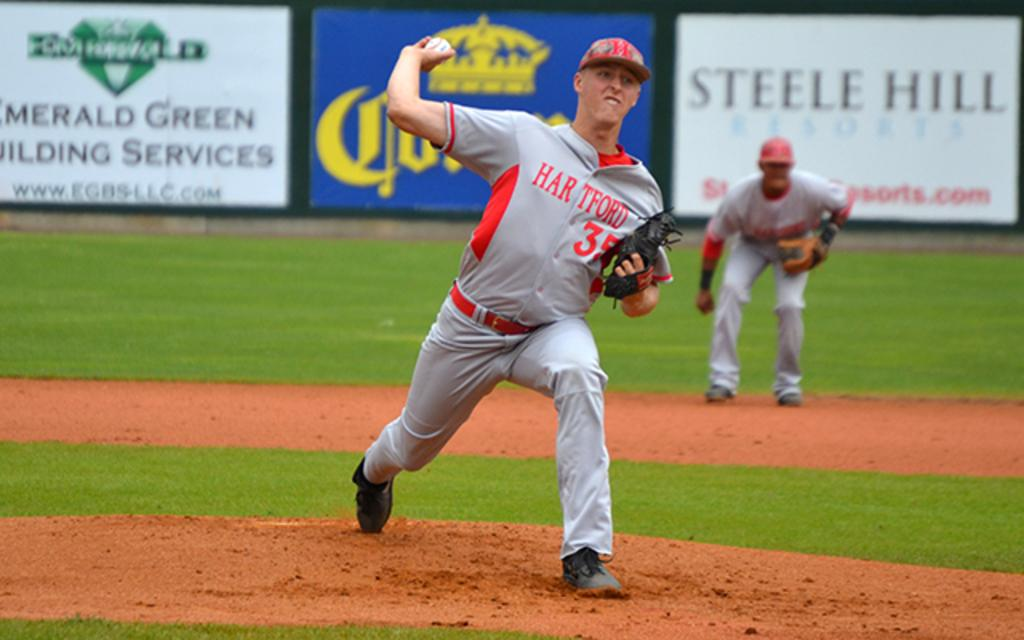<image>
Write a terse but informative summary of the picture. hartford player #35 pitches the ball in front of sponsor signs for steele hill resorts and emerald green building services 